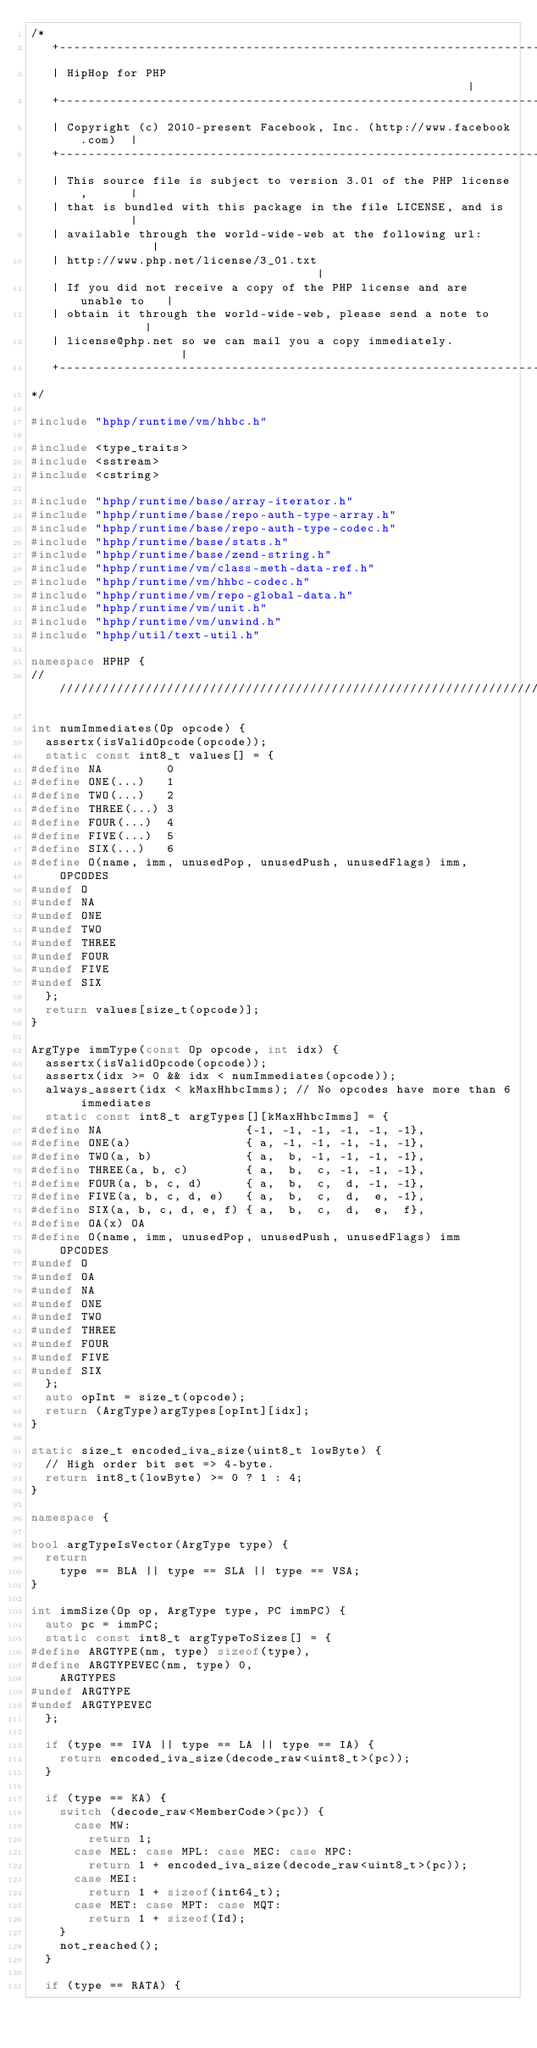Convert code to text. <code><loc_0><loc_0><loc_500><loc_500><_C++_>/*
   +----------------------------------------------------------------------+
   | HipHop for PHP                                                       |
   +----------------------------------------------------------------------+
   | Copyright (c) 2010-present Facebook, Inc. (http://www.facebook.com)  |
   +----------------------------------------------------------------------+
   | This source file is subject to version 3.01 of the PHP license,      |
   | that is bundled with this package in the file LICENSE, and is        |
   | available through the world-wide-web at the following url:           |
   | http://www.php.net/license/3_01.txt                                  |
   | If you did not receive a copy of the PHP license and are unable to   |
   | obtain it through the world-wide-web, please send a note to          |
   | license@php.net so we can mail you a copy immediately.               |
   +----------------------------------------------------------------------+
*/

#include "hphp/runtime/vm/hhbc.h"

#include <type_traits>
#include <sstream>
#include <cstring>

#include "hphp/runtime/base/array-iterator.h"
#include "hphp/runtime/base/repo-auth-type-array.h"
#include "hphp/runtime/base/repo-auth-type-codec.h"
#include "hphp/runtime/base/stats.h"
#include "hphp/runtime/base/zend-string.h"
#include "hphp/runtime/vm/class-meth-data-ref.h"
#include "hphp/runtime/vm/hhbc-codec.h"
#include "hphp/runtime/vm/repo-global-data.h"
#include "hphp/runtime/vm/unit.h"
#include "hphp/runtime/vm/unwind.h"
#include "hphp/util/text-util.h"

namespace HPHP {
///////////////////////////////////////////////////////////////////////////////

int numImmediates(Op opcode) {
  assertx(isValidOpcode(opcode));
  static const int8_t values[] = {
#define NA         0
#define ONE(...)   1
#define TWO(...)   2
#define THREE(...) 3
#define FOUR(...)  4
#define FIVE(...)  5
#define SIX(...)   6
#define O(name, imm, unusedPop, unusedPush, unusedFlags) imm,
    OPCODES
#undef O
#undef NA
#undef ONE
#undef TWO
#undef THREE
#undef FOUR
#undef FIVE
#undef SIX
  };
  return values[size_t(opcode)];
}

ArgType immType(const Op opcode, int idx) {
  assertx(isValidOpcode(opcode));
  assertx(idx >= 0 && idx < numImmediates(opcode));
  always_assert(idx < kMaxHhbcImms); // No opcodes have more than 6 immediates
  static const int8_t argTypes[][kMaxHhbcImms] = {
#define NA                    {-1, -1, -1, -1, -1, -1},
#define ONE(a)                { a, -1, -1, -1, -1, -1},
#define TWO(a, b)             { a,  b, -1, -1, -1, -1},
#define THREE(a, b, c)        { a,  b,  c, -1, -1, -1},
#define FOUR(a, b, c, d)      { a,  b,  c,  d, -1, -1},
#define FIVE(a, b, c, d, e)   { a,  b,  c,  d,  e, -1},
#define SIX(a, b, c, d, e, f) { a,  b,  c,  d,  e,  f},
#define OA(x) OA
#define O(name, imm, unusedPop, unusedPush, unusedFlags) imm
    OPCODES
#undef O
#undef OA
#undef NA
#undef ONE
#undef TWO
#undef THREE
#undef FOUR
#undef FIVE
#undef SIX
  };
  auto opInt = size_t(opcode);
  return (ArgType)argTypes[opInt][idx];
}

static size_t encoded_iva_size(uint8_t lowByte) {
  // High order bit set => 4-byte.
  return int8_t(lowByte) >= 0 ? 1 : 4;
}

namespace {

bool argTypeIsVector(ArgType type) {
  return
    type == BLA || type == SLA || type == VSA;
}

int immSize(Op op, ArgType type, PC immPC) {
  auto pc = immPC;
  static const int8_t argTypeToSizes[] = {
#define ARGTYPE(nm, type) sizeof(type),
#define ARGTYPEVEC(nm, type) 0,
    ARGTYPES
#undef ARGTYPE
#undef ARGTYPEVEC
  };

  if (type == IVA || type == LA || type == IA) {
    return encoded_iva_size(decode_raw<uint8_t>(pc));
  }

  if (type == KA) {
    switch (decode_raw<MemberCode>(pc)) {
      case MW:
        return 1;
      case MEL: case MPL: case MEC: case MPC:
        return 1 + encoded_iva_size(decode_raw<uint8_t>(pc));
      case MEI:
        return 1 + sizeof(int64_t);
      case MET: case MPT: case MQT:
        return 1 + sizeof(Id);
    }
    not_reached();
  }

  if (type == RATA) {</code> 